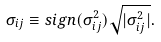Convert formula to latex. <formula><loc_0><loc_0><loc_500><loc_500>\sigma _ { i j } \equiv s i g n ( \sigma ^ { 2 } _ { i j } ) \sqrt { | \sigma ^ { 2 } _ { i j } | } .</formula> 